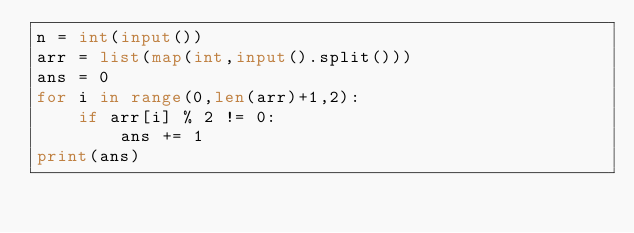<code> <loc_0><loc_0><loc_500><loc_500><_Python_>n = int(input())
arr = list(map(int,input().split()))
ans = 0
for i in range(0,len(arr)+1,2):
    if arr[i] % 2 != 0:
        ans += 1
print(ans)</code> 